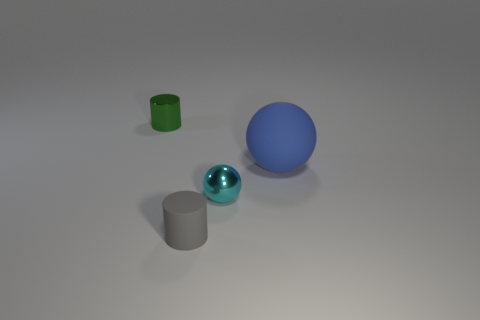Add 1 big blue rubber balls. How many objects exist? 5 Subtract 0 yellow cylinders. How many objects are left? 4 Subtract all tiny matte things. Subtract all red balls. How many objects are left? 3 Add 1 shiny cylinders. How many shiny cylinders are left? 2 Add 3 matte cylinders. How many matte cylinders exist? 4 